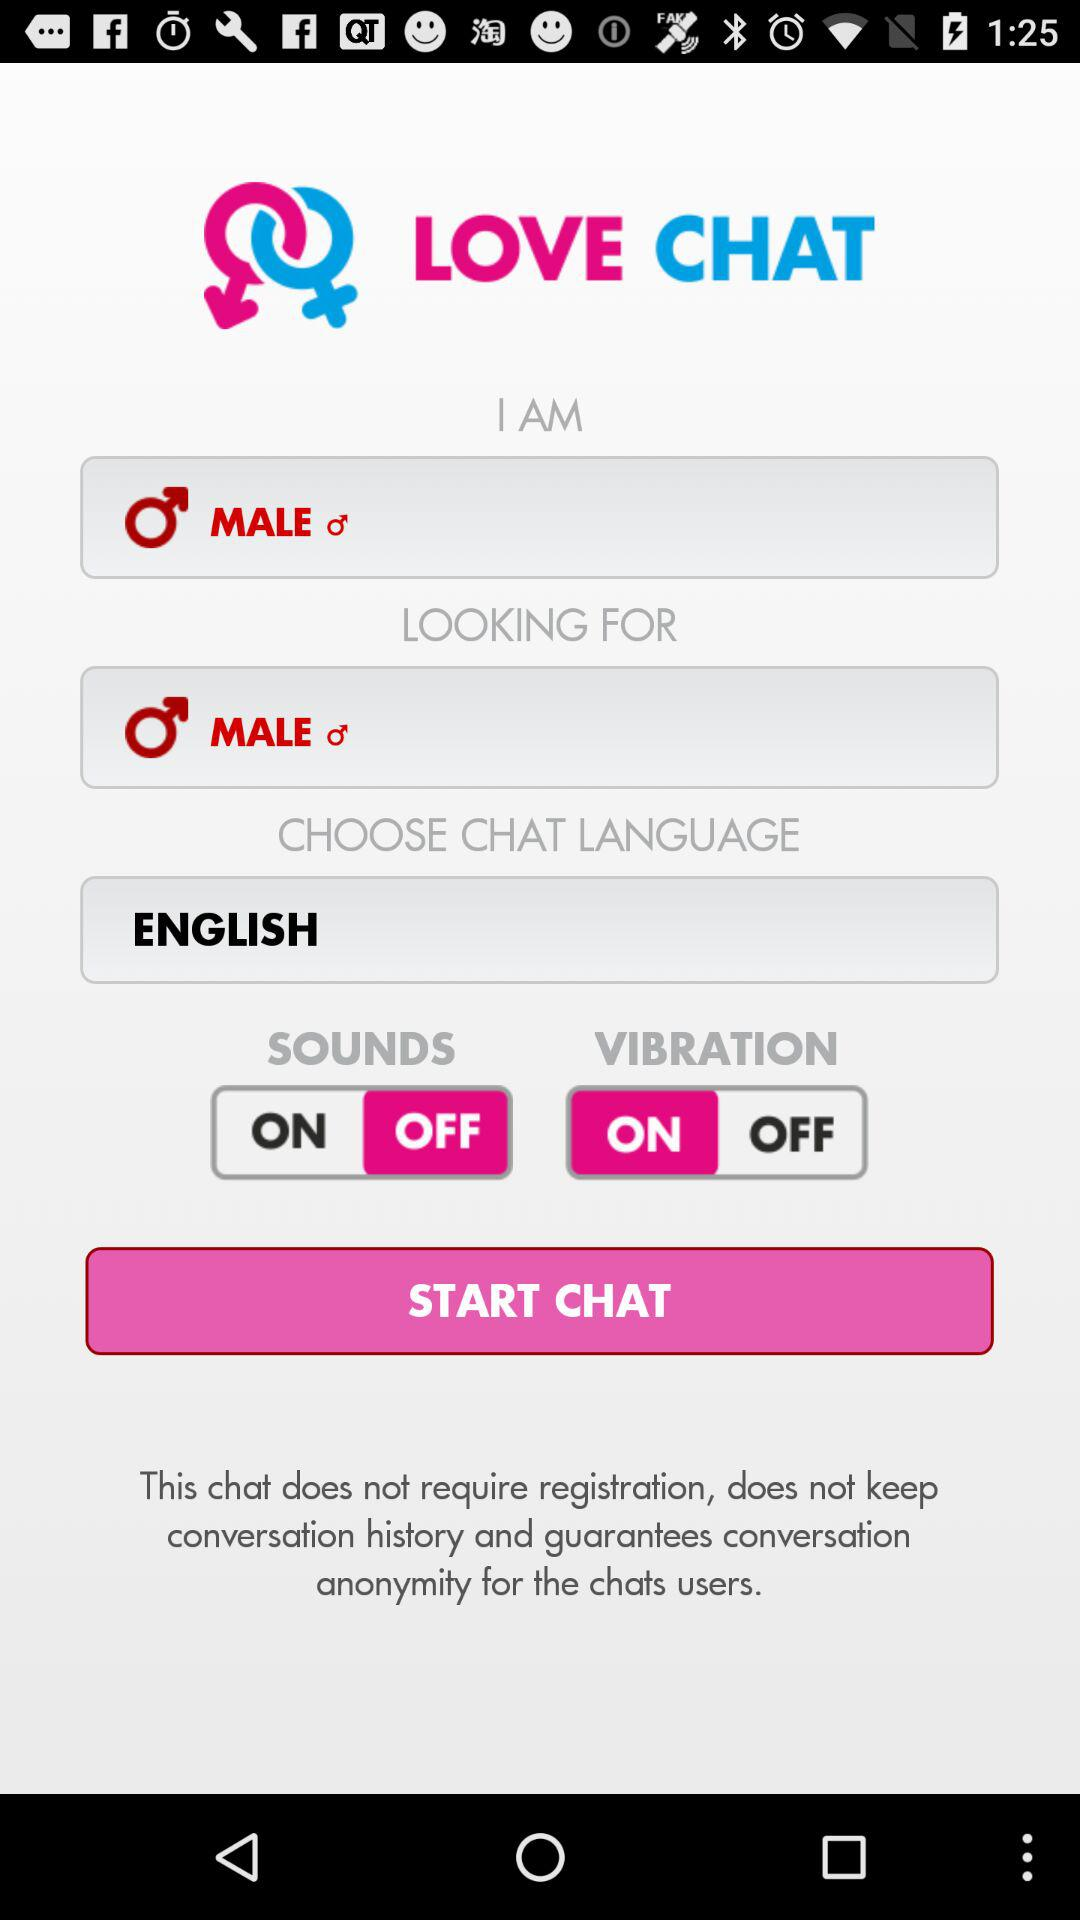What is the status of "SOUNDS"? The status is "off". 